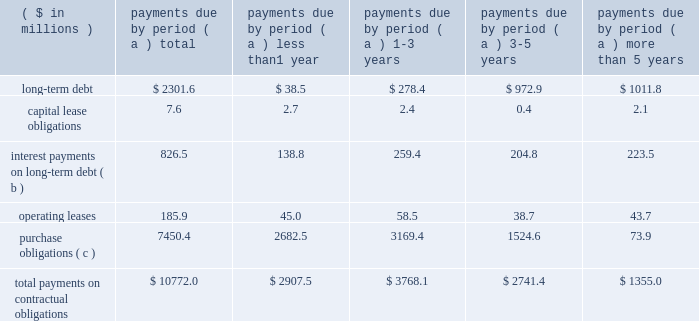Page 31 of 98 additional details about the company 2019s receivables sales agreement and debt are available in notes 6 and 12 , respectively , accompanying the consolidated financial statements within item 8 of this report .
Other liquidity items cash payments required for long-term debt maturities , rental payments under noncancellable operating leases and purchase obligations in effect at december 31 , 2006 , are summarized in the table: .
Total payments on contractual obligations $ 10772.0 $ 2907.5 $ 3768.1 $ 2741.4 $ 1355.0 ( a ) amounts reported in local currencies have been translated at the year-end exchange rates .
( b ) for variable rate facilities , amounts are based on interest rates in effect at year end .
( c ) the company 2019s purchase obligations include contracted amounts for aluminum , steel , plastic resin and other direct materials .
Also included are commitments for purchases of natural gas and electricity , aerospace and technologies contracts and other less significant items .
In cases where variable prices and/or usage are involved , management 2019s best estimates have been used .
Depending on the circumstances , early termination of the contracts may not result in penalties and , therefore , actual payments could vary significantly .
Contributions to the company 2019s defined benefit pension plans , not including the unfunded german plans , are expected to be $ 69.1 million in 2007 .
This estimate may change based on plan asset performance .
Benefit payments related to these plans are expected to be $ 62.6 million , $ 65.1 million , $ 68.9 million , $ 73.9 million and $ 75.1 million for the years ending december 31 , 2007 through 2011 , respectively , and $ 436.7 million combined for 2012 through 2016 .
Payments to participants in the unfunded german plans are expected to be $ 24.6 million , $ 25.1 million , $ 25.5 million , $ 25.9 million and $ 26.1 million in the years 2007 through 2011 , respectively , and a total of $ 136.6 million thereafter .
We reduced our share repurchase program in 2006 to $ 45.7 million , net of issuances , compared to $ 358.1 million net repurchases in 2005 and $ 50 million in 2004 .
The net repurchases in 2006 did not include a forward contract entered into in december 2006 for the repurchase of 1200000 shares .
The contract was settled on january 5 , 2007 , for $ 51.9 million in cash .
In 2007 we expect to repurchase approximately $ 175 million , net of issuances , and to reduce debt levels by more than $ 125 million .
Annual cash dividends paid on common stock were 40 cents per share in 2006 and 2005 and 35 cents per share in 2004 .
Total dividends paid were $ 41 million in 2006 , $ 42.5 million in 2005 and $ 38.9 million in 2004. .
What is the percentage reduction in the spending on the share repurchase program in 2006 compared to 2005?\\n? 
Computations: ((358.1 - 45.7) / 358.1)
Answer: 0.87238. 